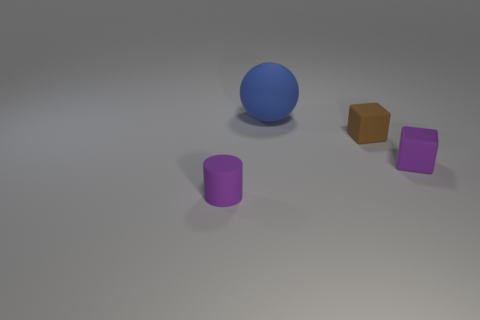Add 3 tiny purple objects. How many objects exist? 7 Subtract all spheres. How many objects are left? 3 Subtract all matte things. Subtract all small cyan matte cubes. How many objects are left? 0 Add 3 rubber blocks. How many rubber blocks are left? 5 Add 2 small brown metallic balls. How many small brown metallic balls exist? 2 Subtract 0 gray blocks. How many objects are left? 4 